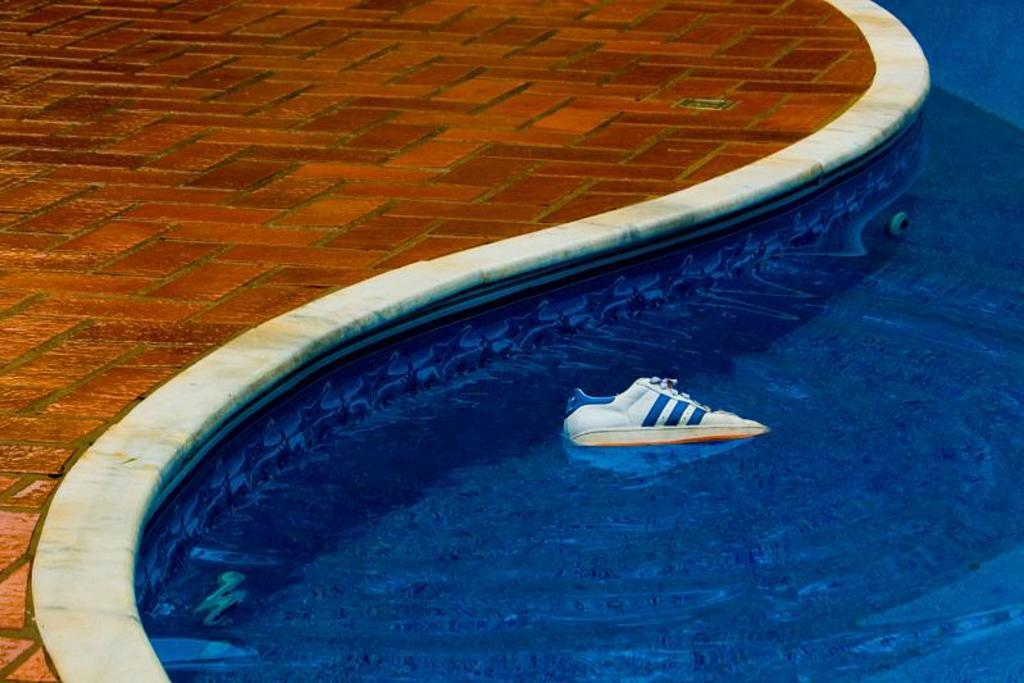What object is in the swimming pool in the image? There is a shoe in the swimming pool in the image. What can be seen in the background of the image? There is a road visible in the image. Can you tell if the image was taken during the day or night? The image may have been taken during the night, as there is no visible sunlight. What type of horn can be heard in the image? There is no horn present in the image, and therefore no sound can be heard. Is there a guide present in the image to help with navigation? There is no guide present in the image; it only features a shoe in the swimming pool and a road in the background. 